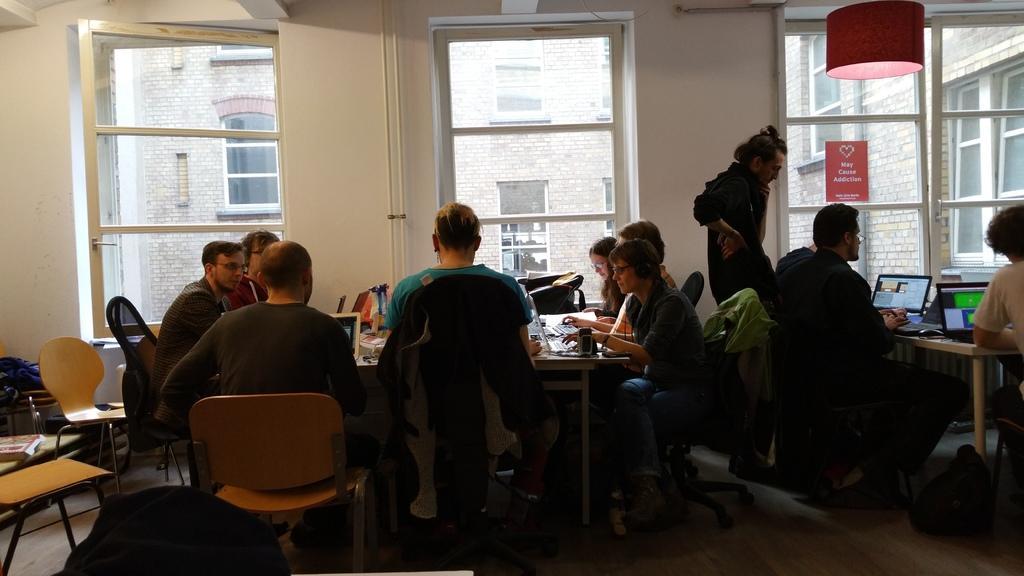Describe this image in one or two sentences. As we can see in the image there is wall, window, pipe, building and few people sitting on chairs and there is a table. On table there are laptops and papers. 